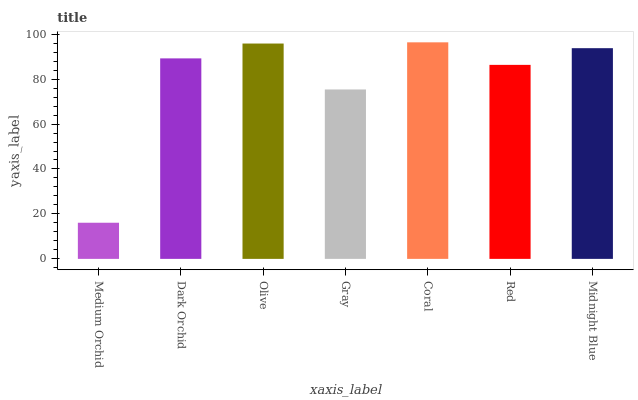Is Medium Orchid the minimum?
Answer yes or no. Yes. Is Coral the maximum?
Answer yes or no. Yes. Is Dark Orchid the minimum?
Answer yes or no. No. Is Dark Orchid the maximum?
Answer yes or no. No. Is Dark Orchid greater than Medium Orchid?
Answer yes or no. Yes. Is Medium Orchid less than Dark Orchid?
Answer yes or no. Yes. Is Medium Orchid greater than Dark Orchid?
Answer yes or no. No. Is Dark Orchid less than Medium Orchid?
Answer yes or no. No. Is Dark Orchid the high median?
Answer yes or no. Yes. Is Dark Orchid the low median?
Answer yes or no. Yes. Is Olive the high median?
Answer yes or no. No. Is Red the low median?
Answer yes or no. No. 